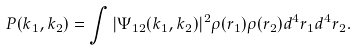Convert formula to latex. <formula><loc_0><loc_0><loc_500><loc_500>P ( k _ { 1 } , k _ { 2 } ) = \int | \Psi _ { 1 2 } ( k _ { 1 } , k _ { 2 } ) | ^ { 2 } \rho ( r _ { 1 } ) \rho ( r _ { 2 } ) d ^ { 4 } r _ { 1 } d ^ { 4 } r _ { 2 } .</formula> 